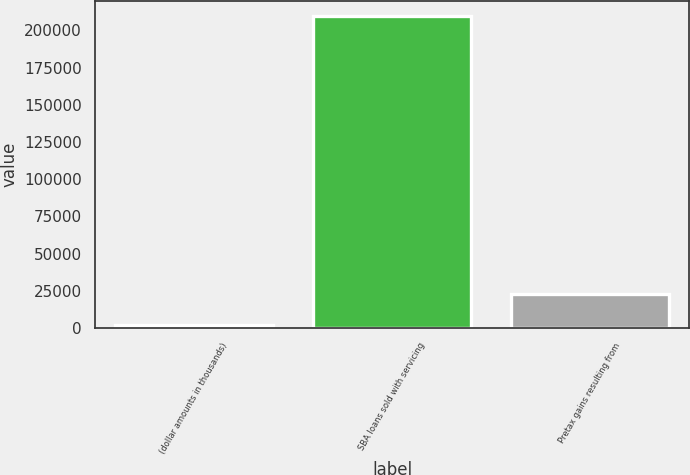Convert chart. <chart><loc_0><loc_0><loc_500><loc_500><bar_chart><fcel>(dollar amounts in thousands)<fcel>SBA loans sold with servicing<fcel>Pretax gains resulting from<nl><fcel>2012<fcel>209540<fcel>22916<nl></chart> 